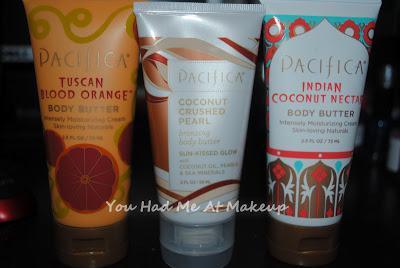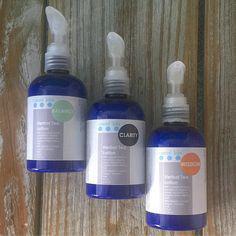The first image is the image on the left, the second image is the image on the right. Analyze the images presented: Is the assertion "An image shows only pump-top products." valid? Answer yes or no. Yes. The first image is the image on the left, the second image is the image on the right. Assess this claim about the two images: "Two bottles of lotion stand together in the image on the left.". Correct or not? Answer yes or no. No. 